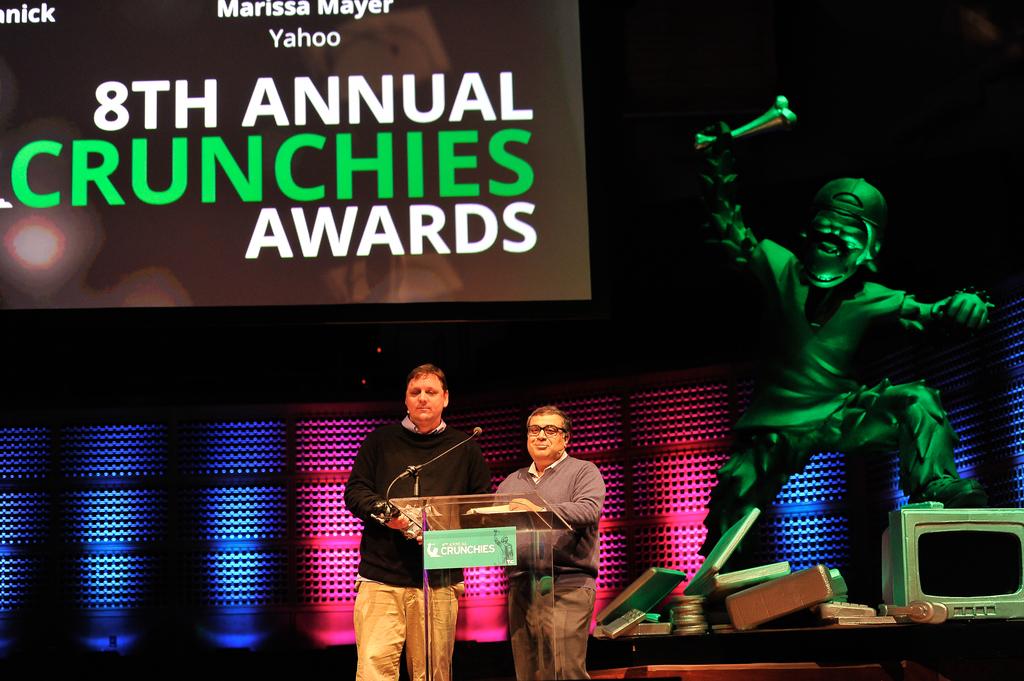What awards show are they at?
Give a very brief answer. Crunchies. How many of these awards have taken place?
Make the answer very short. 8. 